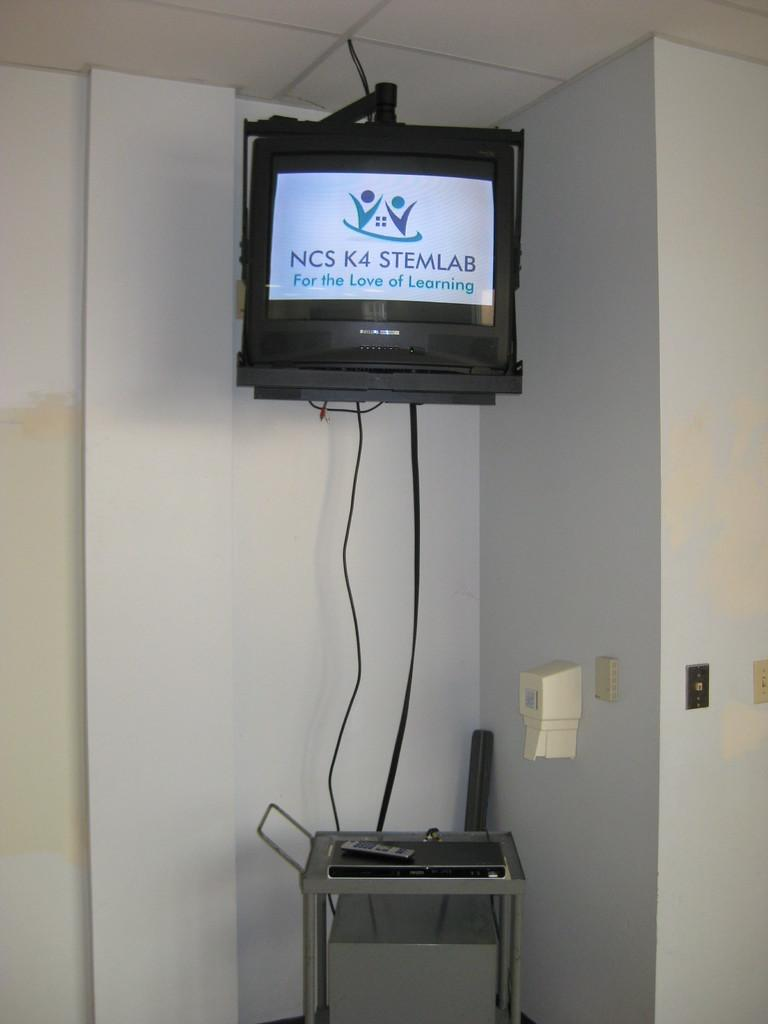What is the main object in the center of the image? There is a television in the center of the image. Where is the stool located in relation to the television? The stool is at the bottom side of the image. What is placed on the stool? There is a remote on the stool. How many girls are sitting on the stool in the image? There are no girls present in the image; it only features a television, a stool, and a remote. 